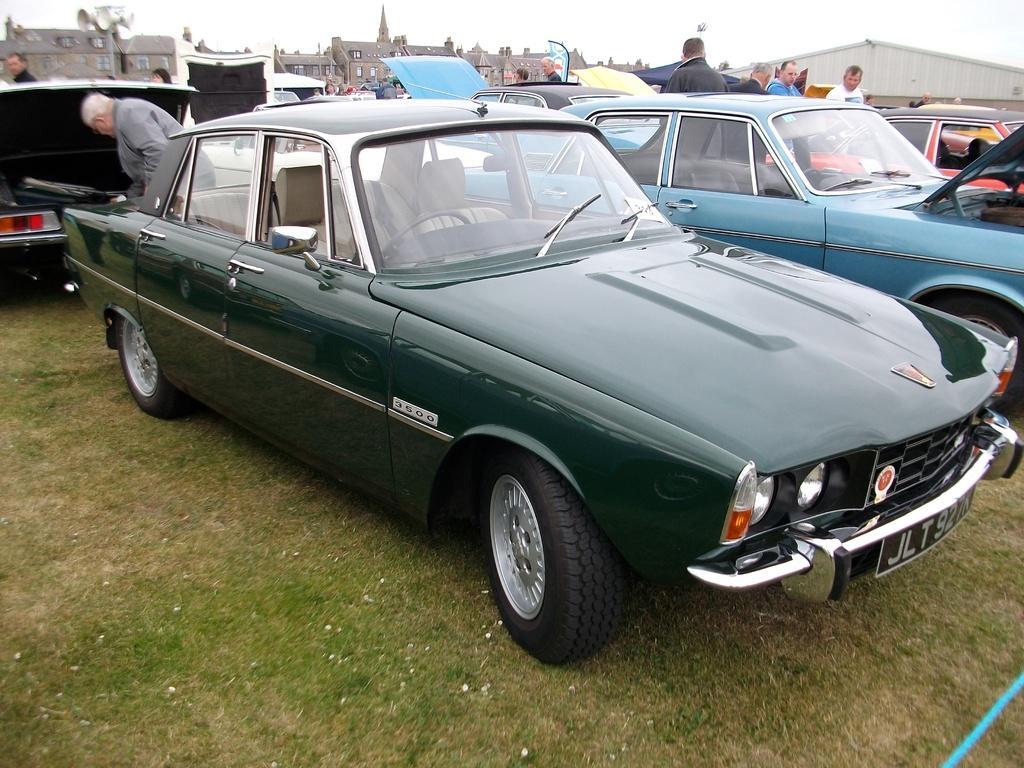Describe this image in one or two sentences. In this image we can see motor vehicles on the ground, persons standing on the ground, speakers attached to a pole, buildings, shed and sky. 